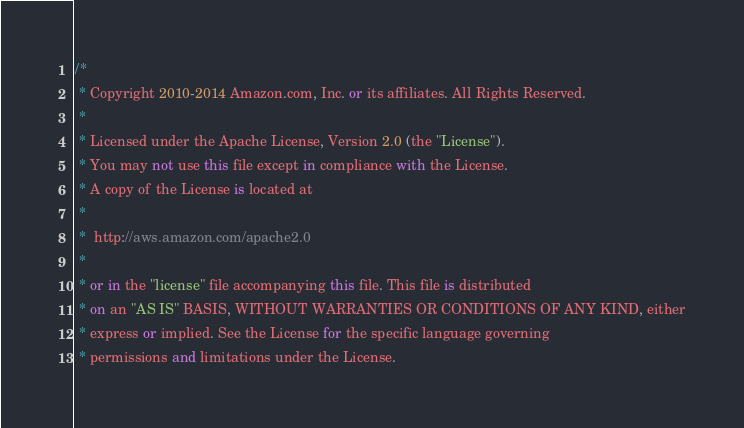Convert code to text. <code><loc_0><loc_0><loc_500><loc_500><_C#_>/*
 * Copyright 2010-2014 Amazon.com, Inc. or its affiliates. All Rights Reserved.
 * 
 * Licensed under the Apache License, Version 2.0 (the "License").
 * You may not use this file except in compliance with the License.
 * A copy of the License is located at
 * 
 *  http://aws.amazon.com/apache2.0
 * 
 * or in the "license" file accompanying this file. This file is distributed
 * on an "AS IS" BASIS, WITHOUT WARRANTIES OR CONDITIONS OF ANY KIND, either
 * express or implied. See the License for the specific language governing
 * permissions and limitations under the License.</code> 